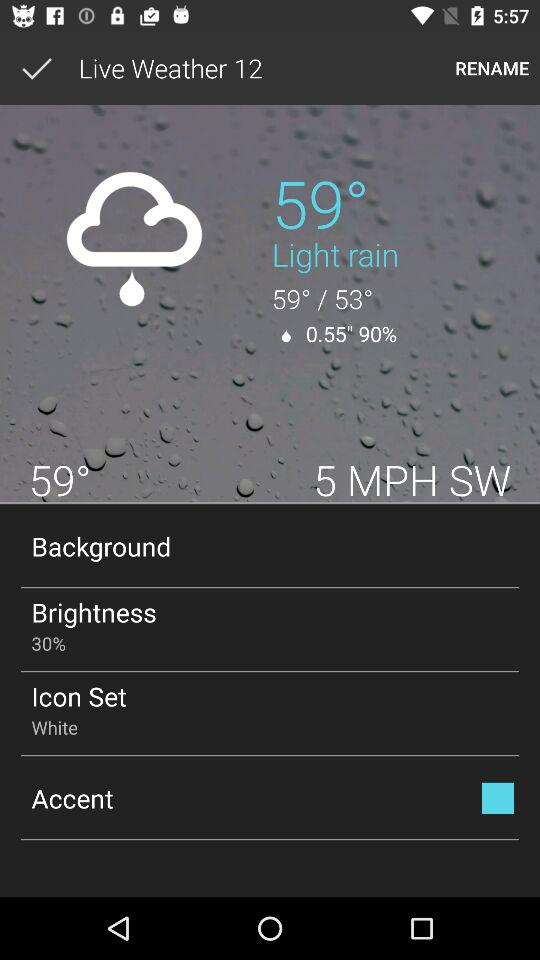What is the setting for the icon set? The setting for the icon set is "White". 